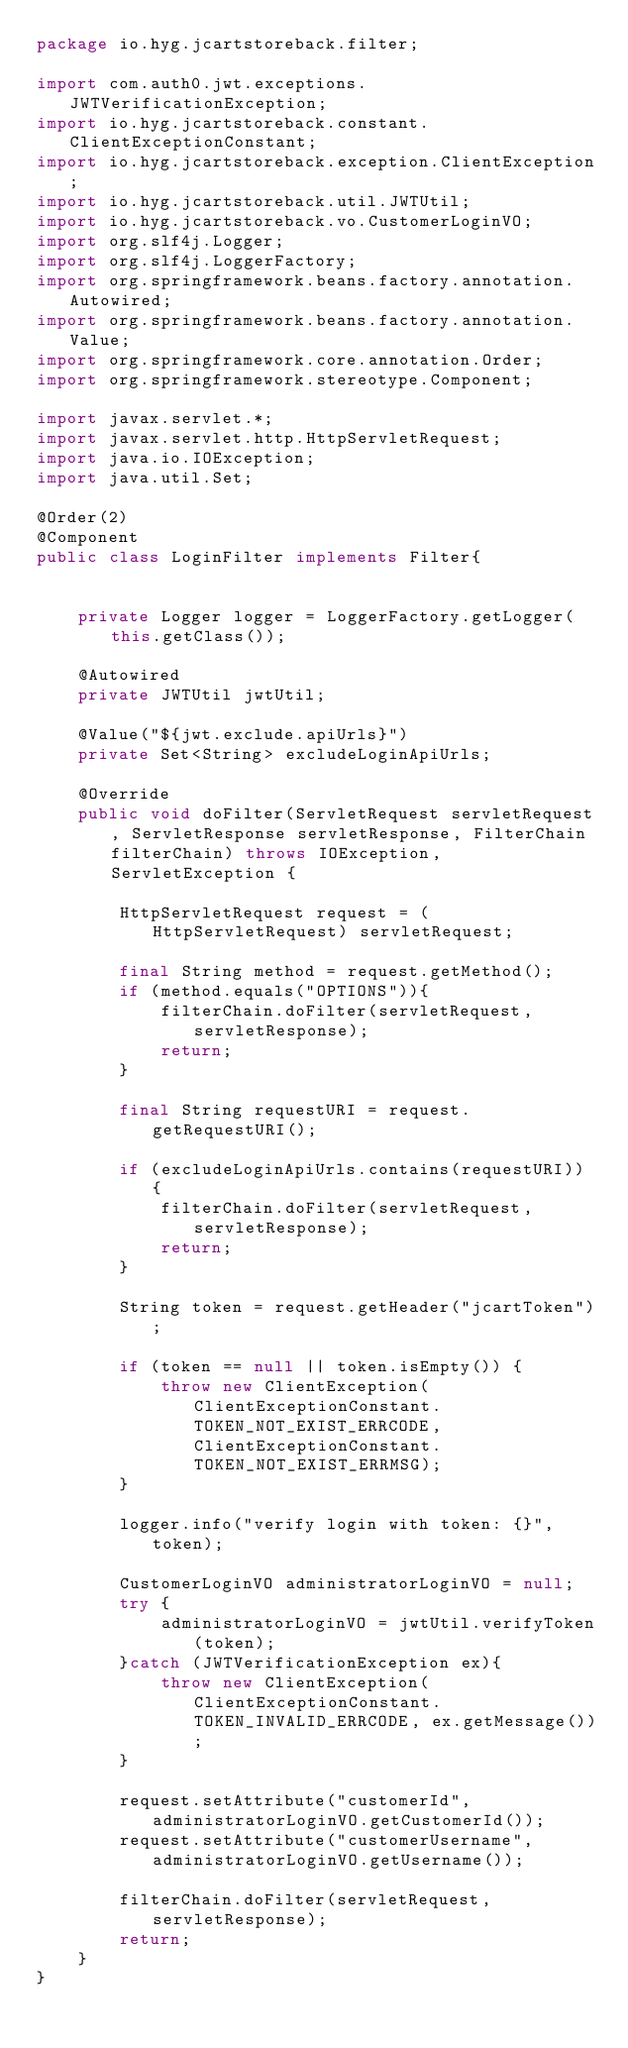<code> <loc_0><loc_0><loc_500><loc_500><_Java_>package io.hyg.jcartstoreback.filter;

import com.auth0.jwt.exceptions.JWTVerificationException;
import io.hyg.jcartstoreback.constant.ClientExceptionConstant;
import io.hyg.jcartstoreback.exception.ClientException;
import io.hyg.jcartstoreback.util.JWTUtil;
import io.hyg.jcartstoreback.vo.CustomerLoginVO;
import org.slf4j.Logger;
import org.slf4j.LoggerFactory;
import org.springframework.beans.factory.annotation.Autowired;
import org.springframework.beans.factory.annotation.Value;
import org.springframework.core.annotation.Order;
import org.springframework.stereotype.Component;

import javax.servlet.*;
import javax.servlet.http.HttpServletRequest;
import java.io.IOException;
import java.util.Set;

@Order(2)
@Component
public class LoginFilter implements Filter{


    private Logger logger = LoggerFactory.getLogger(this.getClass());

    @Autowired
    private JWTUtil jwtUtil;

    @Value("${jwt.exclude.apiUrls}")
    private Set<String> excludeLoginApiUrls;

    @Override
    public void doFilter(ServletRequest servletRequest, ServletResponse servletResponse, FilterChain filterChain) throws IOException, ServletException {

        HttpServletRequest request = (HttpServletRequest) servletRequest;

        final String method = request.getMethod();
        if (method.equals("OPTIONS")){
            filterChain.doFilter(servletRequest, servletResponse);
            return;
        }

        final String requestURI = request.getRequestURI();

        if (excludeLoginApiUrls.contains(requestURI)) {
            filterChain.doFilter(servletRequest, servletResponse);
            return;
        }

        String token = request.getHeader("jcartToken");

        if (token == null || token.isEmpty()) {
            throw new ClientException(ClientExceptionConstant.TOKEN_NOT_EXIST_ERRCODE, ClientExceptionConstant.TOKEN_NOT_EXIST_ERRMSG);
        }

        logger.info("verify login with token: {}", token);

        CustomerLoginVO administratorLoginVO = null;
        try {
            administratorLoginVO = jwtUtil.verifyToken(token);
        }catch (JWTVerificationException ex){
            throw new ClientException(ClientExceptionConstant.TOKEN_INVALID_ERRCODE, ex.getMessage());
        }

        request.setAttribute("customerId", administratorLoginVO.getCustomerId());
        request.setAttribute("customerUsername", administratorLoginVO.getUsername());

        filterChain.doFilter(servletRequest, servletResponse);
        return;
    }
}
</code> 